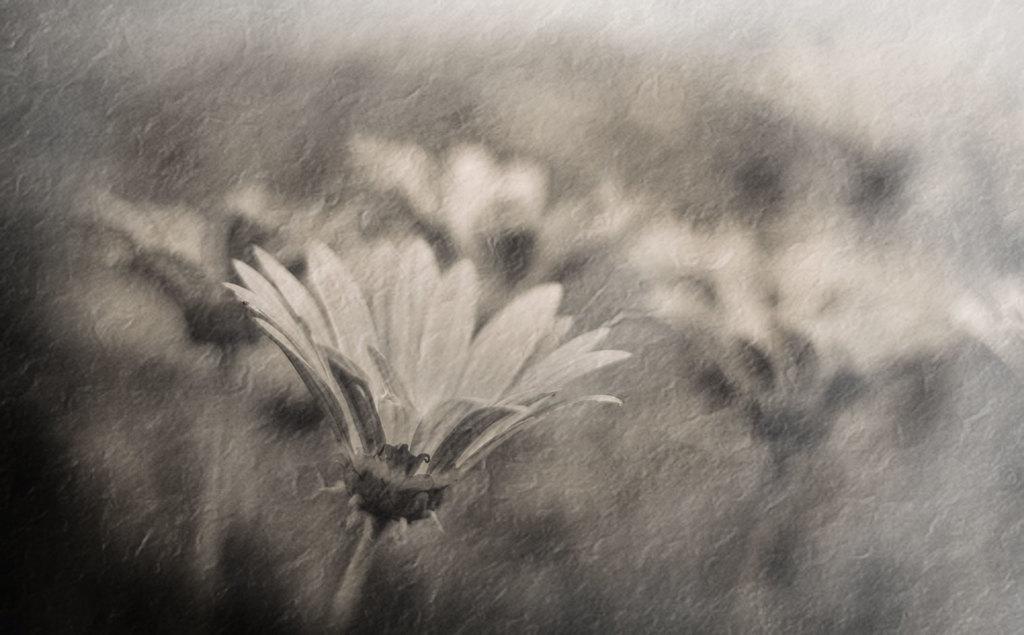Please provide a concise description of this image. In this picture we can see few flowers. Background is blurry. 